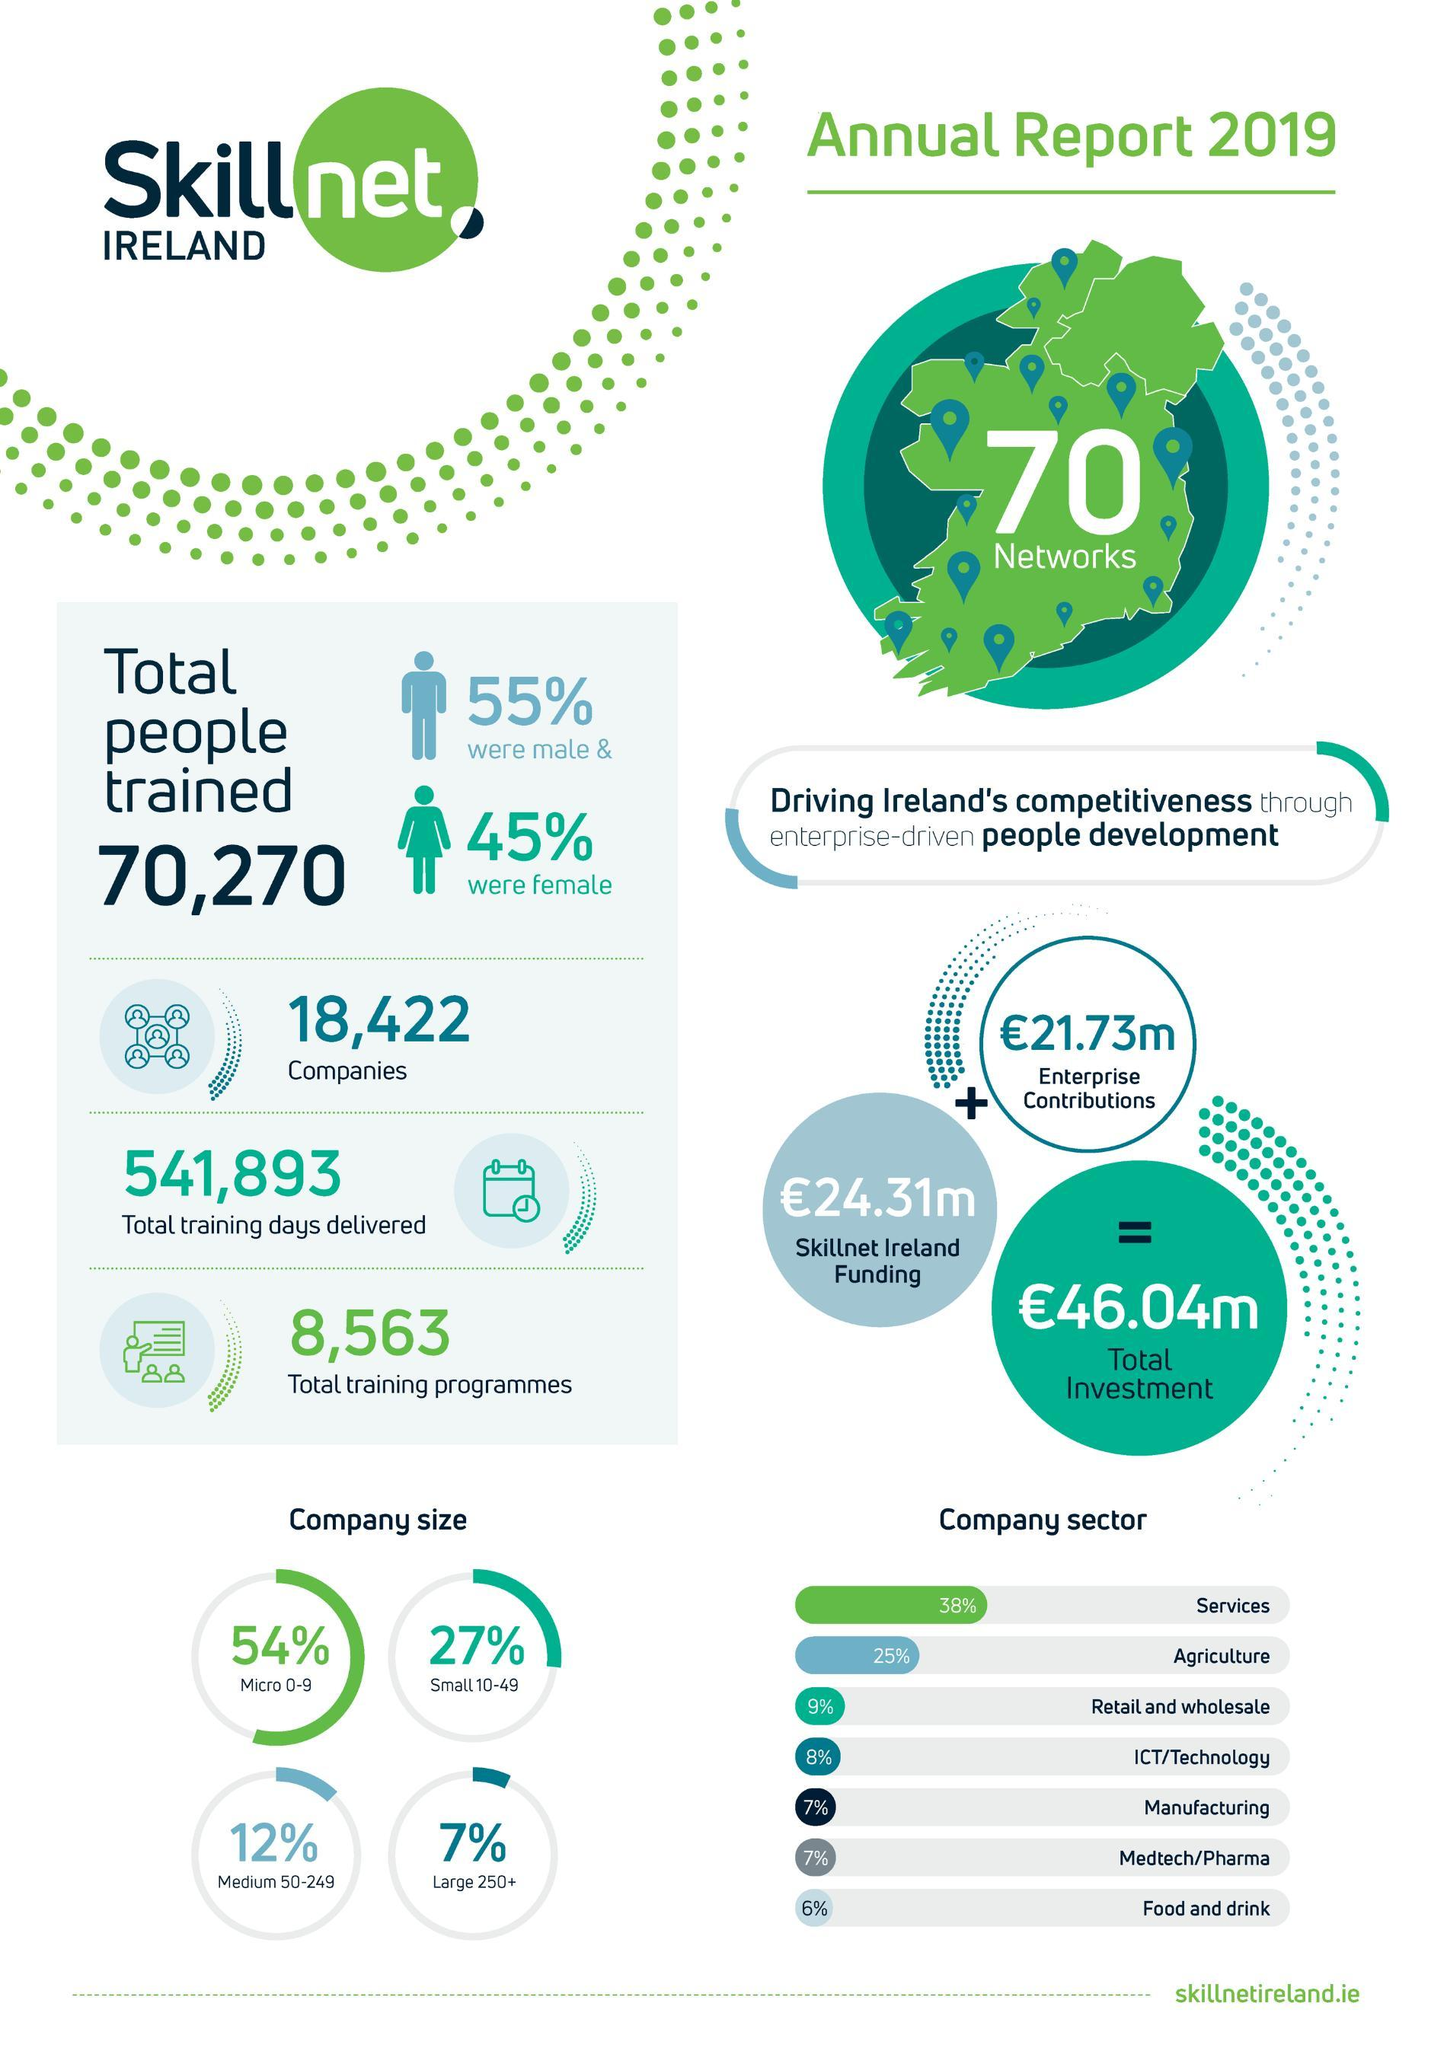What is the percentage of small sized companies Trained by Skillnet Ireland, 54%, 27%, or  25%?
Answer the question with a short phrase. 27% What was the percentage of manufacturing and pharma companies trained Skillnet? 7% 